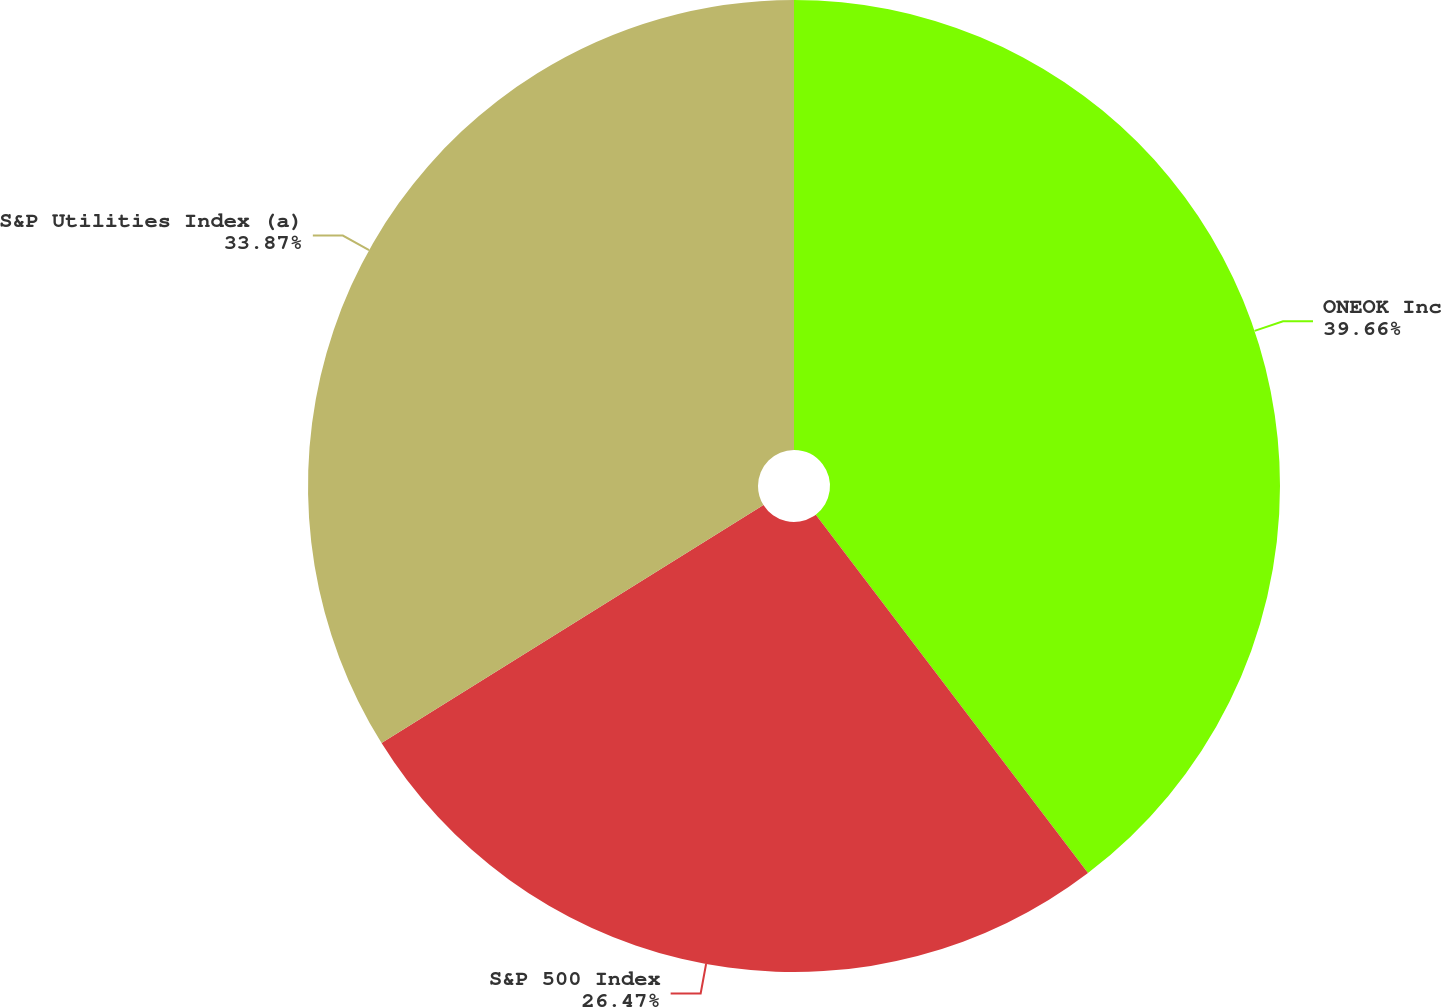<chart> <loc_0><loc_0><loc_500><loc_500><pie_chart><fcel>ONEOK Inc<fcel>S&P 500 Index<fcel>S&P Utilities Index (a)<nl><fcel>39.66%<fcel>26.47%<fcel>33.87%<nl></chart> 